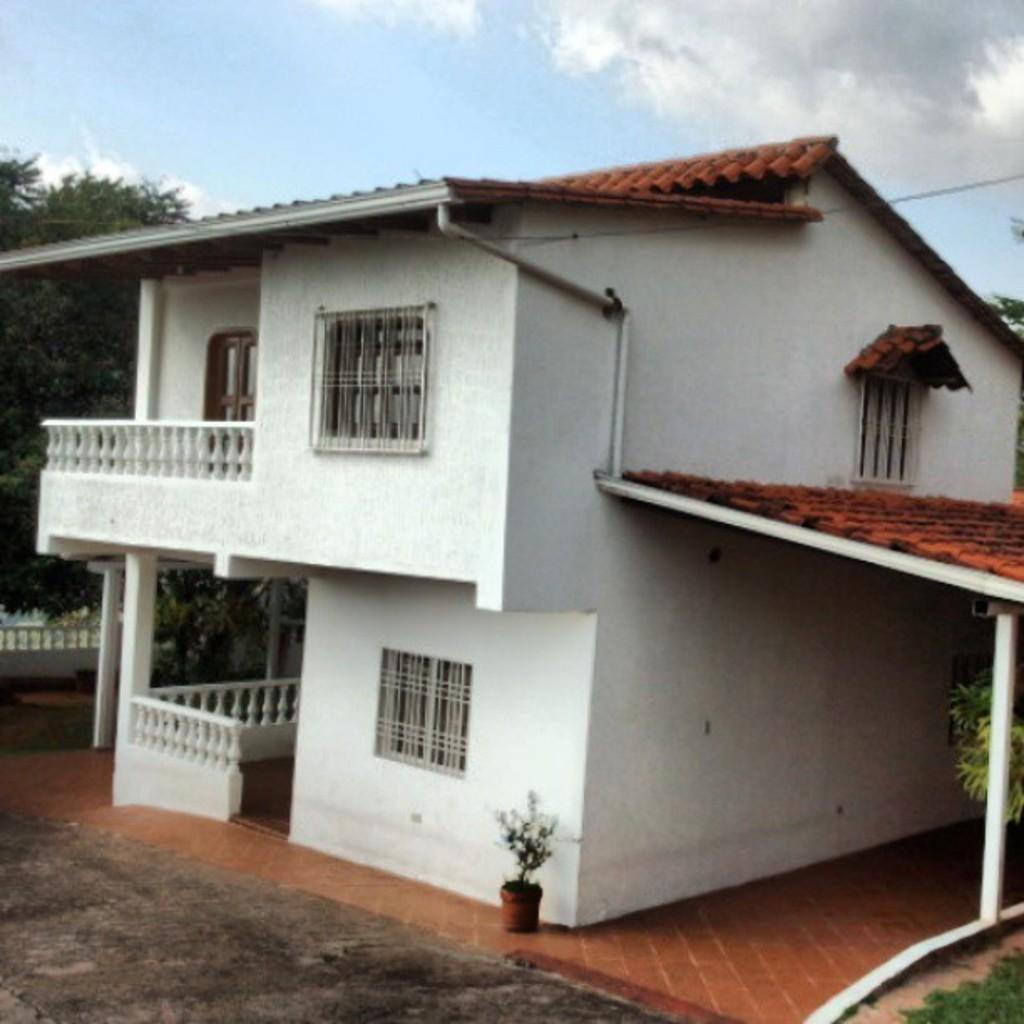What type of structure is visible in the image? The image contains the roof of a house. What type of vegetation can be seen in the image? There is a plant, grass, and trees visible in the image. What type of barrier is present in the image? There is a fencing wall in the image. What type of surface is visible in the image? There is a path in the image. What is visible at the top of the image? The sky is visible at the top of the image. What can be seen in the sky? Clouds are present in the sky. What type of thread is used to create the map in the image? There is no map or thread present in the image. 